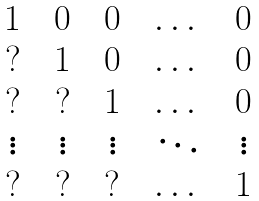<formula> <loc_0><loc_0><loc_500><loc_500>\begin{matrix} 1 & & 0 & & 0 & & \dots & & 0 \\ ? & & 1 & & 0 & & \dots & & 0 \\ ? & & ? & & 1 & & \dots & & 0 \\ \vdots & & \vdots & & \vdots & & \ddots & & \vdots \\ ? & & ? & & ? & & \dots & & 1 \end{matrix}</formula> 